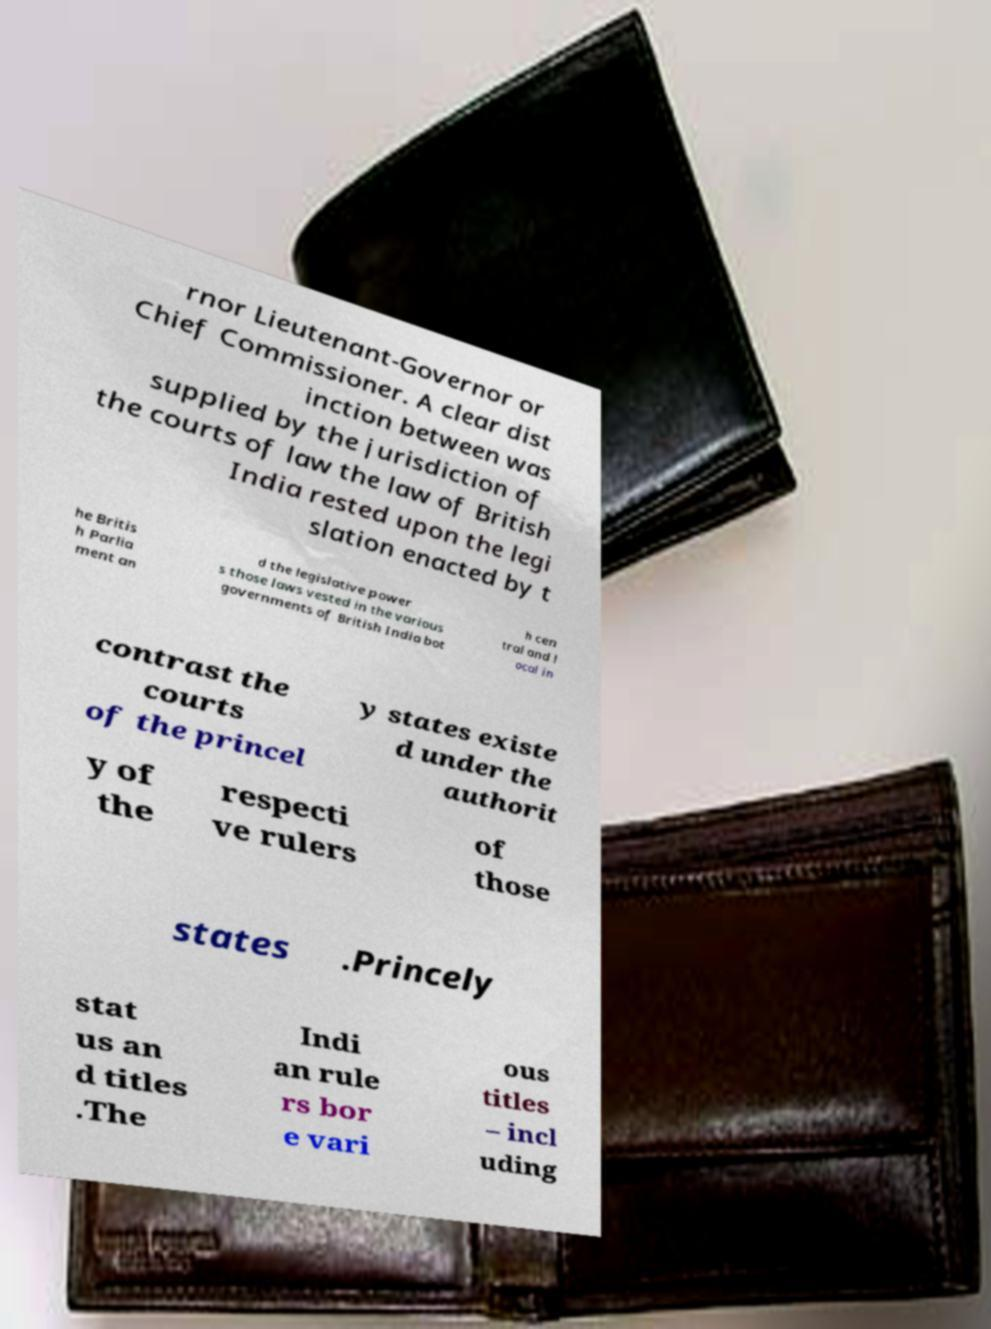Please identify and transcribe the text found in this image. rnor Lieutenant-Governor or Chief Commissioner. A clear dist inction between was supplied by the jurisdiction of the courts of law the law of British India rested upon the legi slation enacted by t he Britis h Parlia ment an d the legislative power s those laws vested in the various governments of British India bot h cen tral and l ocal in contrast the courts of the princel y states existe d under the authorit y of the respecti ve rulers of those states .Princely stat us an d titles .The Indi an rule rs bor e vari ous titles – incl uding 